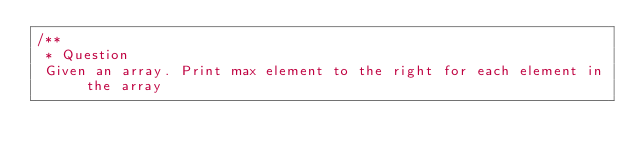<code> <loc_0><loc_0><loc_500><loc_500><_Java_>/**
 * Question
 Given an array. Print max element to the right for each element in the array</code> 